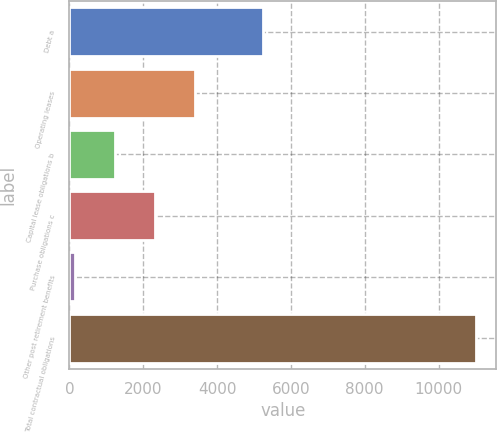Convert chart. <chart><loc_0><loc_0><loc_500><loc_500><bar_chart><fcel>Debt a<fcel>Operating leases<fcel>Capital lease obligations b<fcel>Purchase obligations c<fcel>Other post retirement benefits<fcel>Total contractual obligations<nl><fcel>5232<fcel>3412.4<fcel>1238.8<fcel>2325.6<fcel>152<fcel>11020<nl></chart> 